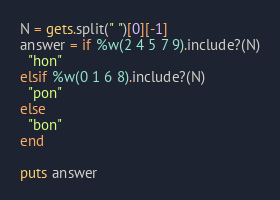Convert code to text. <code><loc_0><loc_0><loc_500><loc_500><_Ruby_>N = gets.split(" ")[0][-1]
answer = if %w(2 4 5 7 9).include?(N)
  "hon"
elsif %w(0 1 6 8).include?(N)
  "pon"
else
  "bon"
end

puts answer
</code> 